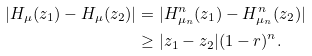Convert formula to latex. <formula><loc_0><loc_0><loc_500><loc_500>| H _ { \mu } ( z _ { 1 } ) - H _ { \mu } ( z _ { 2 } ) | & = | H ^ { n } _ { \mu _ { n } } ( z _ { 1 } ) - H ^ { n } _ { \mu _ { n } } ( z _ { 2 } ) | \\ & \geq | z _ { 1 } - z _ { 2 } | ( 1 - r ) ^ { n } .</formula> 